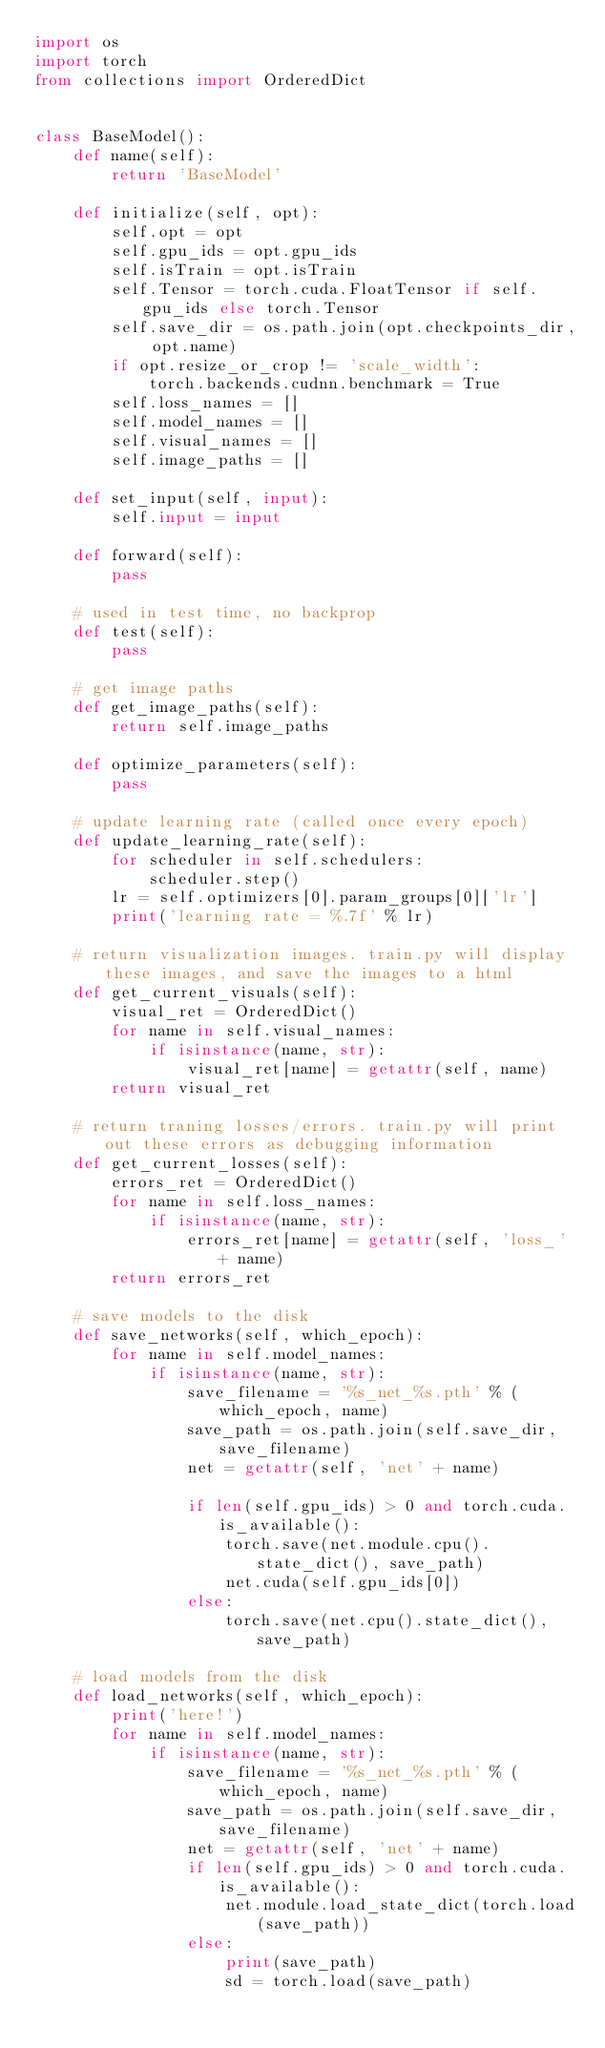<code> <loc_0><loc_0><loc_500><loc_500><_Python_>import os
import torch
from collections import OrderedDict


class BaseModel():
    def name(self):
        return 'BaseModel'

    def initialize(self, opt):
        self.opt = opt
        self.gpu_ids = opt.gpu_ids
        self.isTrain = opt.isTrain
        self.Tensor = torch.cuda.FloatTensor if self.gpu_ids else torch.Tensor
        self.save_dir = os.path.join(opt.checkpoints_dir, opt.name)
        if opt.resize_or_crop != 'scale_width':
            torch.backends.cudnn.benchmark = True
        self.loss_names = []
        self.model_names = []
        self.visual_names = []
        self.image_paths = []

    def set_input(self, input):
        self.input = input

    def forward(self):
        pass

    # used in test time, no backprop
    def test(self):
        pass

    # get image paths
    def get_image_paths(self):
        return self.image_paths

    def optimize_parameters(self):
        pass

    # update learning rate (called once every epoch)
    def update_learning_rate(self):
        for scheduler in self.schedulers:
            scheduler.step()
        lr = self.optimizers[0].param_groups[0]['lr']
        print('learning rate = %.7f' % lr)

    # return visualization images. train.py will display these images, and save the images to a html
    def get_current_visuals(self):
        visual_ret = OrderedDict()
        for name in self.visual_names:
            if isinstance(name, str):
                visual_ret[name] = getattr(self, name)
        return visual_ret

    # return traning losses/errors. train.py will print out these errors as debugging information
    def get_current_losses(self):
        errors_ret = OrderedDict()
        for name in self.loss_names:
            if isinstance(name, str):
                errors_ret[name] = getattr(self, 'loss_' + name)
        return errors_ret

    # save models to the disk
    def save_networks(self, which_epoch):
        for name in self.model_names:
            if isinstance(name, str):
                save_filename = '%s_net_%s.pth' % (which_epoch, name)
                save_path = os.path.join(self.save_dir, save_filename)
                net = getattr(self, 'net' + name)

                if len(self.gpu_ids) > 0 and torch.cuda.is_available():
                    torch.save(net.module.cpu().state_dict(), save_path)
                    net.cuda(self.gpu_ids[0])
                else:
                    torch.save(net.cpu().state_dict(), save_path)

    # load models from the disk
    def load_networks(self, which_epoch):
        print('here!')
        for name in self.model_names:
            if isinstance(name, str):
                save_filename = '%s_net_%s.pth' % (which_epoch, name)
                save_path = os.path.join(self.save_dir, save_filename)
                net = getattr(self, 'net' + name)
                if len(self.gpu_ids) > 0 and torch.cuda.is_available():
                    net.module.load_state_dict(torch.load(save_path))
                else:
                    print(save_path)
                    sd = torch.load(save_path)</code> 